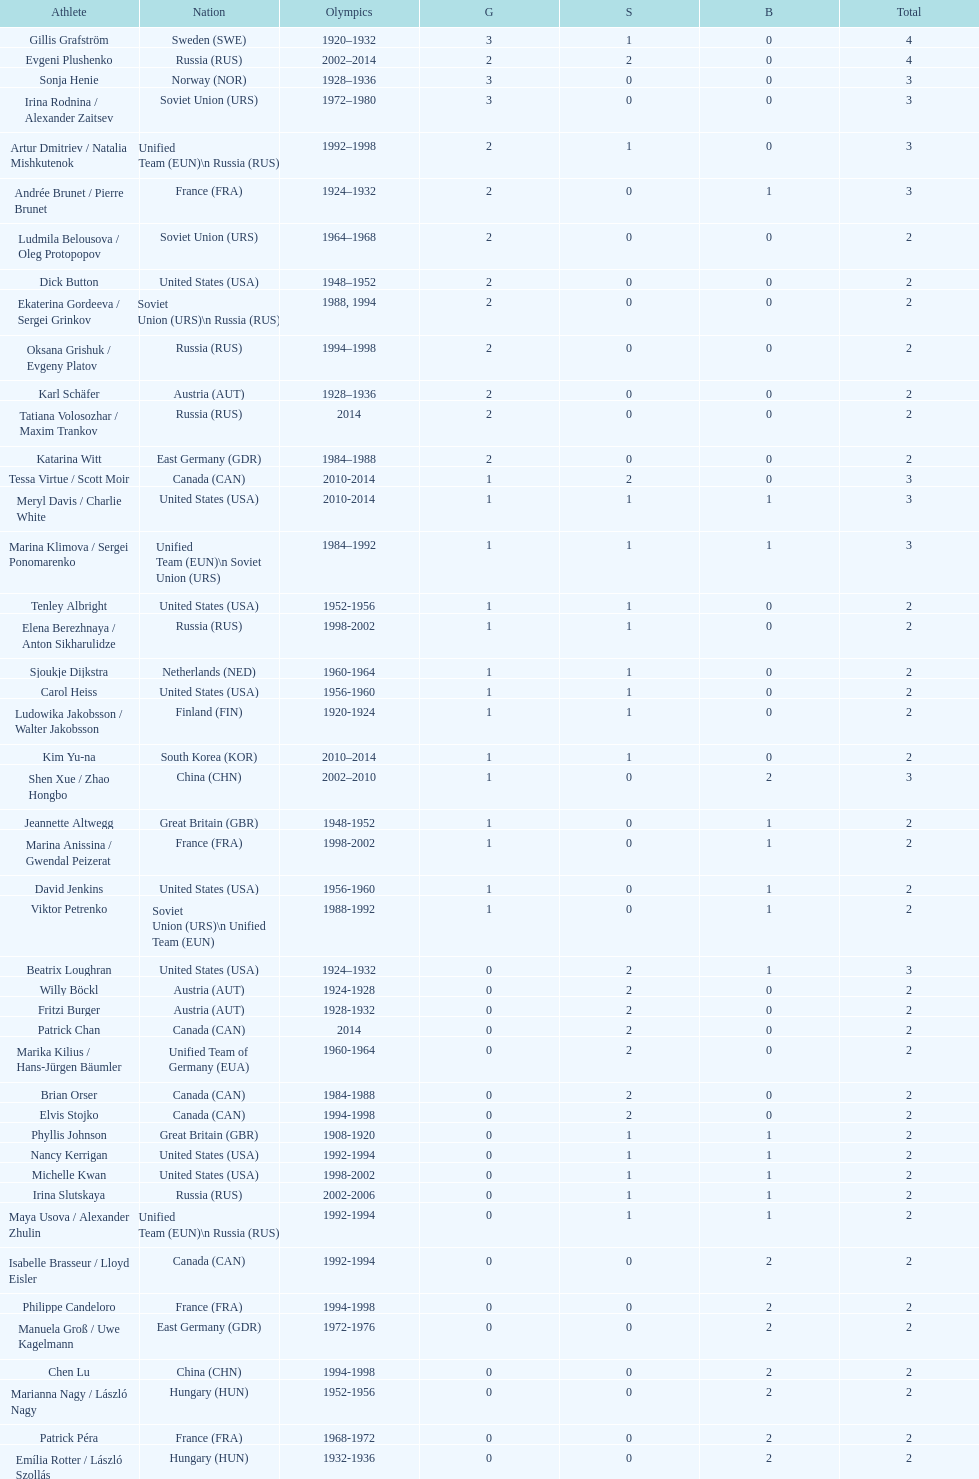What was the greatest number of gold medals won by a single athlete? 3. 